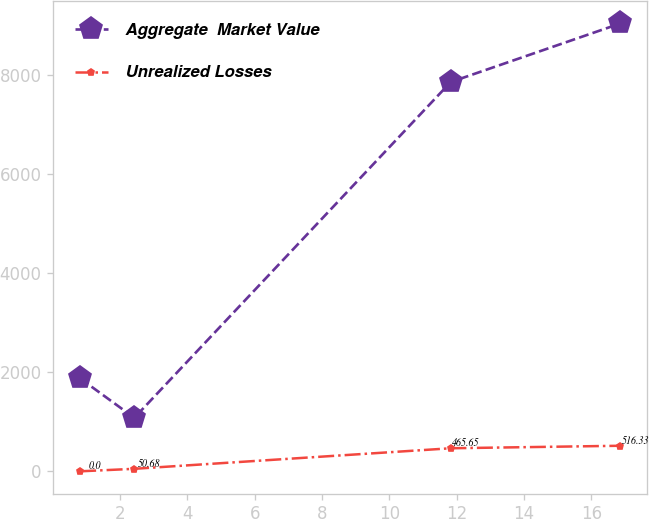Convert chart to OTSL. <chart><loc_0><loc_0><loc_500><loc_500><line_chart><ecel><fcel>Aggregate  Market Value<fcel>Unrealized Losses<nl><fcel>0.81<fcel>1876.89<fcel>0<nl><fcel>2.42<fcel>1080.39<fcel>50.68<nl><fcel>11.82<fcel>7862.15<fcel>465.65<nl><fcel>16.86<fcel>9045.35<fcel>516.33<nl></chart> 